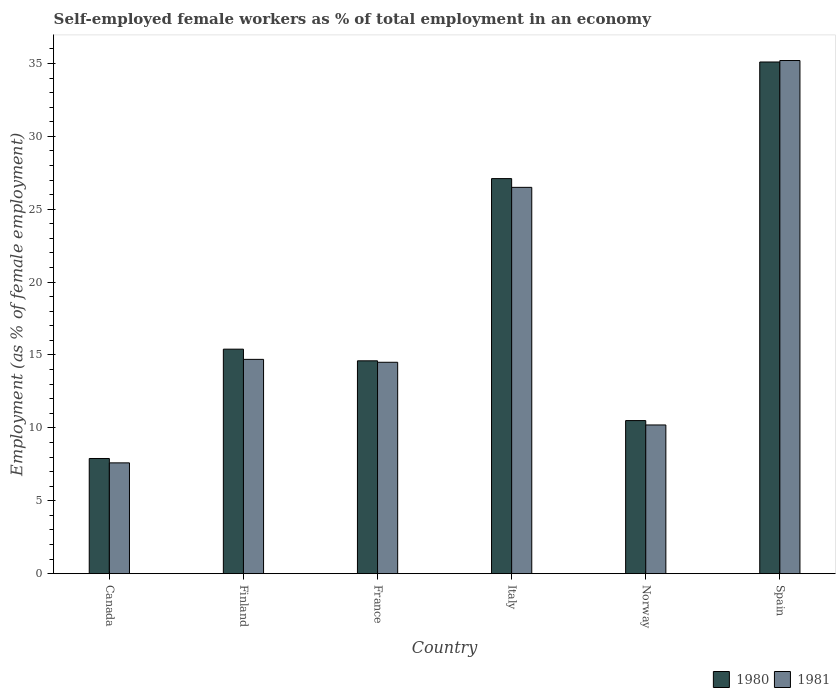How many different coloured bars are there?
Keep it short and to the point. 2. Are the number of bars per tick equal to the number of legend labels?
Give a very brief answer. Yes. In how many cases, is the number of bars for a given country not equal to the number of legend labels?
Give a very brief answer. 0. What is the percentage of self-employed female workers in 1980 in Finland?
Provide a succinct answer. 15.4. Across all countries, what is the maximum percentage of self-employed female workers in 1981?
Give a very brief answer. 35.2. Across all countries, what is the minimum percentage of self-employed female workers in 1981?
Provide a short and direct response. 7.6. In which country was the percentage of self-employed female workers in 1981 minimum?
Ensure brevity in your answer.  Canada. What is the total percentage of self-employed female workers in 1981 in the graph?
Provide a short and direct response. 108.7. What is the difference between the percentage of self-employed female workers in 1980 in Norway and that in Spain?
Make the answer very short. -24.6. What is the difference between the percentage of self-employed female workers in 1980 in France and the percentage of self-employed female workers in 1981 in Norway?
Provide a succinct answer. 4.4. What is the average percentage of self-employed female workers in 1980 per country?
Offer a terse response. 18.43. What is the difference between the percentage of self-employed female workers of/in 1980 and percentage of self-employed female workers of/in 1981 in Norway?
Offer a terse response. 0.3. In how many countries, is the percentage of self-employed female workers in 1981 greater than 29 %?
Make the answer very short. 1. What is the ratio of the percentage of self-employed female workers in 1981 in France to that in Italy?
Offer a very short reply. 0.55. Is the difference between the percentage of self-employed female workers in 1980 in Canada and Italy greater than the difference between the percentage of self-employed female workers in 1981 in Canada and Italy?
Your response must be concise. No. What is the difference between the highest and the second highest percentage of self-employed female workers in 1981?
Keep it short and to the point. -8.7. What is the difference between the highest and the lowest percentage of self-employed female workers in 1980?
Give a very brief answer. 27.2. In how many countries, is the percentage of self-employed female workers in 1980 greater than the average percentage of self-employed female workers in 1980 taken over all countries?
Give a very brief answer. 2. How many bars are there?
Offer a terse response. 12. Are all the bars in the graph horizontal?
Your answer should be very brief. No. How many countries are there in the graph?
Keep it short and to the point. 6. Does the graph contain grids?
Offer a very short reply. No. Where does the legend appear in the graph?
Give a very brief answer. Bottom right. How are the legend labels stacked?
Provide a succinct answer. Horizontal. What is the title of the graph?
Provide a succinct answer. Self-employed female workers as % of total employment in an economy. Does "1969" appear as one of the legend labels in the graph?
Your answer should be compact. No. What is the label or title of the X-axis?
Your answer should be compact. Country. What is the label or title of the Y-axis?
Give a very brief answer. Employment (as % of female employment). What is the Employment (as % of female employment) of 1980 in Canada?
Provide a succinct answer. 7.9. What is the Employment (as % of female employment) in 1981 in Canada?
Keep it short and to the point. 7.6. What is the Employment (as % of female employment) in 1980 in Finland?
Give a very brief answer. 15.4. What is the Employment (as % of female employment) of 1981 in Finland?
Your answer should be compact. 14.7. What is the Employment (as % of female employment) of 1980 in France?
Provide a succinct answer. 14.6. What is the Employment (as % of female employment) in 1980 in Italy?
Your response must be concise. 27.1. What is the Employment (as % of female employment) of 1981 in Italy?
Ensure brevity in your answer.  26.5. What is the Employment (as % of female employment) of 1981 in Norway?
Give a very brief answer. 10.2. What is the Employment (as % of female employment) in 1980 in Spain?
Keep it short and to the point. 35.1. What is the Employment (as % of female employment) of 1981 in Spain?
Your answer should be compact. 35.2. Across all countries, what is the maximum Employment (as % of female employment) of 1980?
Offer a very short reply. 35.1. Across all countries, what is the maximum Employment (as % of female employment) in 1981?
Provide a short and direct response. 35.2. Across all countries, what is the minimum Employment (as % of female employment) in 1980?
Your answer should be very brief. 7.9. Across all countries, what is the minimum Employment (as % of female employment) in 1981?
Offer a terse response. 7.6. What is the total Employment (as % of female employment) of 1980 in the graph?
Offer a terse response. 110.6. What is the total Employment (as % of female employment) of 1981 in the graph?
Your answer should be compact. 108.7. What is the difference between the Employment (as % of female employment) of 1980 in Canada and that in Finland?
Give a very brief answer. -7.5. What is the difference between the Employment (as % of female employment) in 1981 in Canada and that in Finland?
Provide a succinct answer. -7.1. What is the difference between the Employment (as % of female employment) in 1981 in Canada and that in France?
Provide a succinct answer. -6.9. What is the difference between the Employment (as % of female employment) in 1980 in Canada and that in Italy?
Your answer should be compact. -19.2. What is the difference between the Employment (as % of female employment) of 1981 in Canada and that in Italy?
Your answer should be compact. -18.9. What is the difference between the Employment (as % of female employment) in 1980 in Canada and that in Spain?
Your answer should be very brief. -27.2. What is the difference between the Employment (as % of female employment) in 1981 in Canada and that in Spain?
Provide a succinct answer. -27.6. What is the difference between the Employment (as % of female employment) in 1980 in Finland and that in France?
Offer a terse response. 0.8. What is the difference between the Employment (as % of female employment) in 1981 in Finland and that in France?
Give a very brief answer. 0.2. What is the difference between the Employment (as % of female employment) in 1981 in Finland and that in Norway?
Keep it short and to the point. 4.5. What is the difference between the Employment (as % of female employment) of 1980 in Finland and that in Spain?
Provide a short and direct response. -19.7. What is the difference between the Employment (as % of female employment) of 1981 in Finland and that in Spain?
Provide a succinct answer. -20.5. What is the difference between the Employment (as % of female employment) in 1980 in France and that in Italy?
Offer a terse response. -12.5. What is the difference between the Employment (as % of female employment) in 1981 in France and that in Italy?
Your answer should be very brief. -12. What is the difference between the Employment (as % of female employment) of 1980 in France and that in Norway?
Ensure brevity in your answer.  4.1. What is the difference between the Employment (as % of female employment) of 1981 in France and that in Norway?
Provide a succinct answer. 4.3. What is the difference between the Employment (as % of female employment) of 1980 in France and that in Spain?
Provide a short and direct response. -20.5. What is the difference between the Employment (as % of female employment) of 1981 in France and that in Spain?
Give a very brief answer. -20.7. What is the difference between the Employment (as % of female employment) of 1980 in Italy and that in Norway?
Provide a succinct answer. 16.6. What is the difference between the Employment (as % of female employment) of 1981 in Italy and that in Spain?
Give a very brief answer. -8.7. What is the difference between the Employment (as % of female employment) of 1980 in Norway and that in Spain?
Provide a short and direct response. -24.6. What is the difference between the Employment (as % of female employment) in 1980 in Canada and the Employment (as % of female employment) in 1981 in Italy?
Your answer should be compact. -18.6. What is the difference between the Employment (as % of female employment) of 1980 in Canada and the Employment (as % of female employment) of 1981 in Spain?
Offer a terse response. -27.3. What is the difference between the Employment (as % of female employment) in 1980 in Finland and the Employment (as % of female employment) in 1981 in France?
Give a very brief answer. 0.9. What is the difference between the Employment (as % of female employment) in 1980 in Finland and the Employment (as % of female employment) in 1981 in Italy?
Keep it short and to the point. -11.1. What is the difference between the Employment (as % of female employment) in 1980 in Finland and the Employment (as % of female employment) in 1981 in Spain?
Give a very brief answer. -19.8. What is the difference between the Employment (as % of female employment) of 1980 in France and the Employment (as % of female employment) of 1981 in Spain?
Keep it short and to the point. -20.6. What is the difference between the Employment (as % of female employment) of 1980 in Norway and the Employment (as % of female employment) of 1981 in Spain?
Provide a short and direct response. -24.7. What is the average Employment (as % of female employment) in 1980 per country?
Make the answer very short. 18.43. What is the average Employment (as % of female employment) in 1981 per country?
Ensure brevity in your answer.  18.12. What is the difference between the Employment (as % of female employment) of 1980 and Employment (as % of female employment) of 1981 in Canada?
Your response must be concise. 0.3. What is the difference between the Employment (as % of female employment) in 1980 and Employment (as % of female employment) in 1981 in Finland?
Offer a terse response. 0.7. What is the difference between the Employment (as % of female employment) in 1980 and Employment (as % of female employment) in 1981 in Italy?
Make the answer very short. 0.6. What is the difference between the Employment (as % of female employment) of 1980 and Employment (as % of female employment) of 1981 in Norway?
Ensure brevity in your answer.  0.3. What is the ratio of the Employment (as % of female employment) in 1980 in Canada to that in Finland?
Keep it short and to the point. 0.51. What is the ratio of the Employment (as % of female employment) in 1981 in Canada to that in Finland?
Ensure brevity in your answer.  0.52. What is the ratio of the Employment (as % of female employment) of 1980 in Canada to that in France?
Give a very brief answer. 0.54. What is the ratio of the Employment (as % of female employment) of 1981 in Canada to that in France?
Your response must be concise. 0.52. What is the ratio of the Employment (as % of female employment) of 1980 in Canada to that in Italy?
Ensure brevity in your answer.  0.29. What is the ratio of the Employment (as % of female employment) in 1981 in Canada to that in Italy?
Make the answer very short. 0.29. What is the ratio of the Employment (as % of female employment) in 1980 in Canada to that in Norway?
Your answer should be very brief. 0.75. What is the ratio of the Employment (as % of female employment) of 1981 in Canada to that in Norway?
Offer a terse response. 0.75. What is the ratio of the Employment (as % of female employment) of 1980 in Canada to that in Spain?
Your answer should be compact. 0.23. What is the ratio of the Employment (as % of female employment) of 1981 in Canada to that in Spain?
Your answer should be very brief. 0.22. What is the ratio of the Employment (as % of female employment) in 1980 in Finland to that in France?
Give a very brief answer. 1.05. What is the ratio of the Employment (as % of female employment) in 1981 in Finland to that in France?
Offer a very short reply. 1.01. What is the ratio of the Employment (as % of female employment) in 1980 in Finland to that in Italy?
Make the answer very short. 0.57. What is the ratio of the Employment (as % of female employment) of 1981 in Finland to that in Italy?
Make the answer very short. 0.55. What is the ratio of the Employment (as % of female employment) in 1980 in Finland to that in Norway?
Your answer should be compact. 1.47. What is the ratio of the Employment (as % of female employment) of 1981 in Finland to that in Norway?
Keep it short and to the point. 1.44. What is the ratio of the Employment (as % of female employment) of 1980 in Finland to that in Spain?
Offer a very short reply. 0.44. What is the ratio of the Employment (as % of female employment) in 1981 in Finland to that in Spain?
Provide a succinct answer. 0.42. What is the ratio of the Employment (as % of female employment) in 1980 in France to that in Italy?
Offer a very short reply. 0.54. What is the ratio of the Employment (as % of female employment) of 1981 in France to that in Italy?
Keep it short and to the point. 0.55. What is the ratio of the Employment (as % of female employment) of 1980 in France to that in Norway?
Your response must be concise. 1.39. What is the ratio of the Employment (as % of female employment) of 1981 in France to that in Norway?
Offer a terse response. 1.42. What is the ratio of the Employment (as % of female employment) of 1980 in France to that in Spain?
Make the answer very short. 0.42. What is the ratio of the Employment (as % of female employment) in 1981 in France to that in Spain?
Keep it short and to the point. 0.41. What is the ratio of the Employment (as % of female employment) of 1980 in Italy to that in Norway?
Make the answer very short. 2.58. What is the ratio of the Employment (as % of female employment) in 1981 in Italy to that in Norway?
Give a very brief answer. 2.6. What is the ratio of the Employment (as % of female employment) of 1980 in Italy to that in Spain?
Offer a terse response. 0.77. What is the ratio of the Employment (as % of female employment) in 1981 in Italy to that in Spain?
Your response must be concise. 0.75. What is the ratio of the Employment (as % of female employment) in 1980 in Norway to that in Spain?
Ensure brevity in your answer.  0.3. What is the ratio of the Employment (as % of female employment) of 1981 in Norway to that in Spain?
Provide a succinct answer. 0.29. What is the difference between the highest and the second highest Employment (as % of female employment) in 1980?
Your answer should be compact. 8. What is the difference between the highest and the lowest Employment (as % of female employment) in 1980?
Provide a short and direct response. 27.2. What is the difference between the highest and the lowest Employment (as % of female employment) in 1981?
Give a very brief answer. 27.6. 